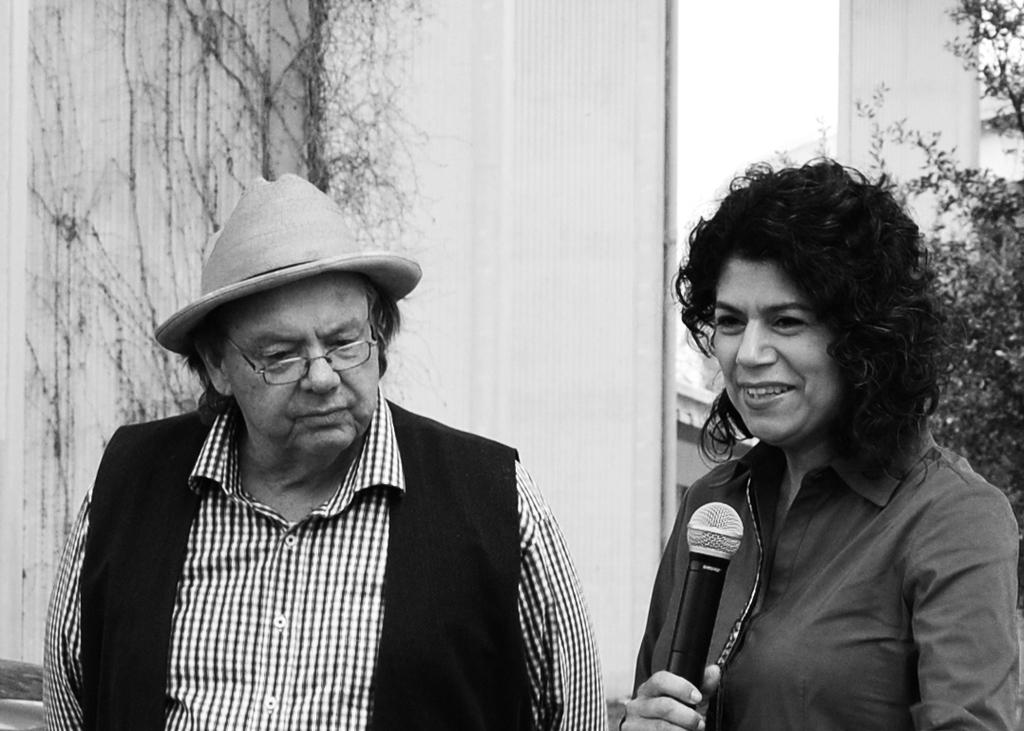Who is present in the image? There is a man and a woman in the image. What are the man and woman holding in the image? The man and woman are holding a mic. What type of toy can be seen in the image? There is no toy present in the image. Is it raining in the image? There is no indication of rain in the image. 